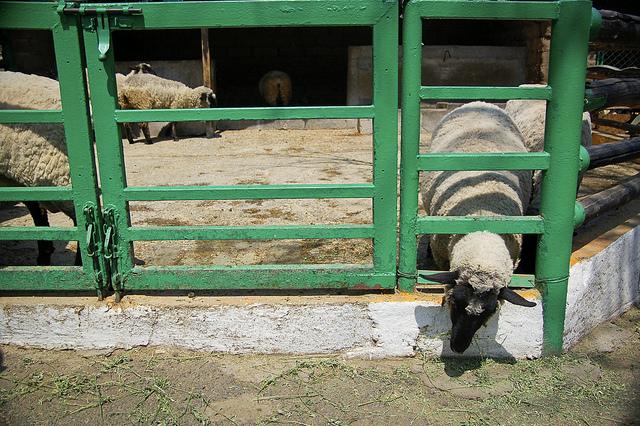Does the gate have a padlock?
Short answer required. No. What color is the gate?
Keep it brief. Green. What animal is shown?
Quick response, please. Sheep. What are on the animal's head?
Short answer required. Ears. What animals are pictured?
Short answer required. Sheep. 